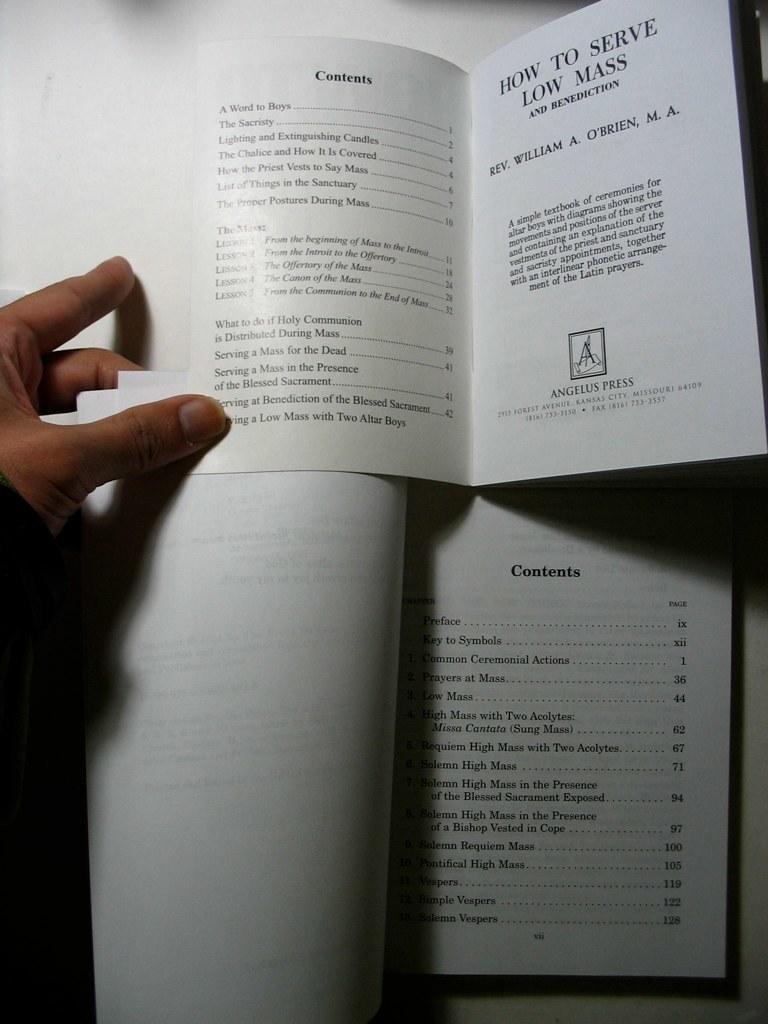Does the book show how to be an alter boy?
Offer a very short reply. Yes. What is the title of the first chapter on the top book?
Offer a very short reply. A word to boys. 